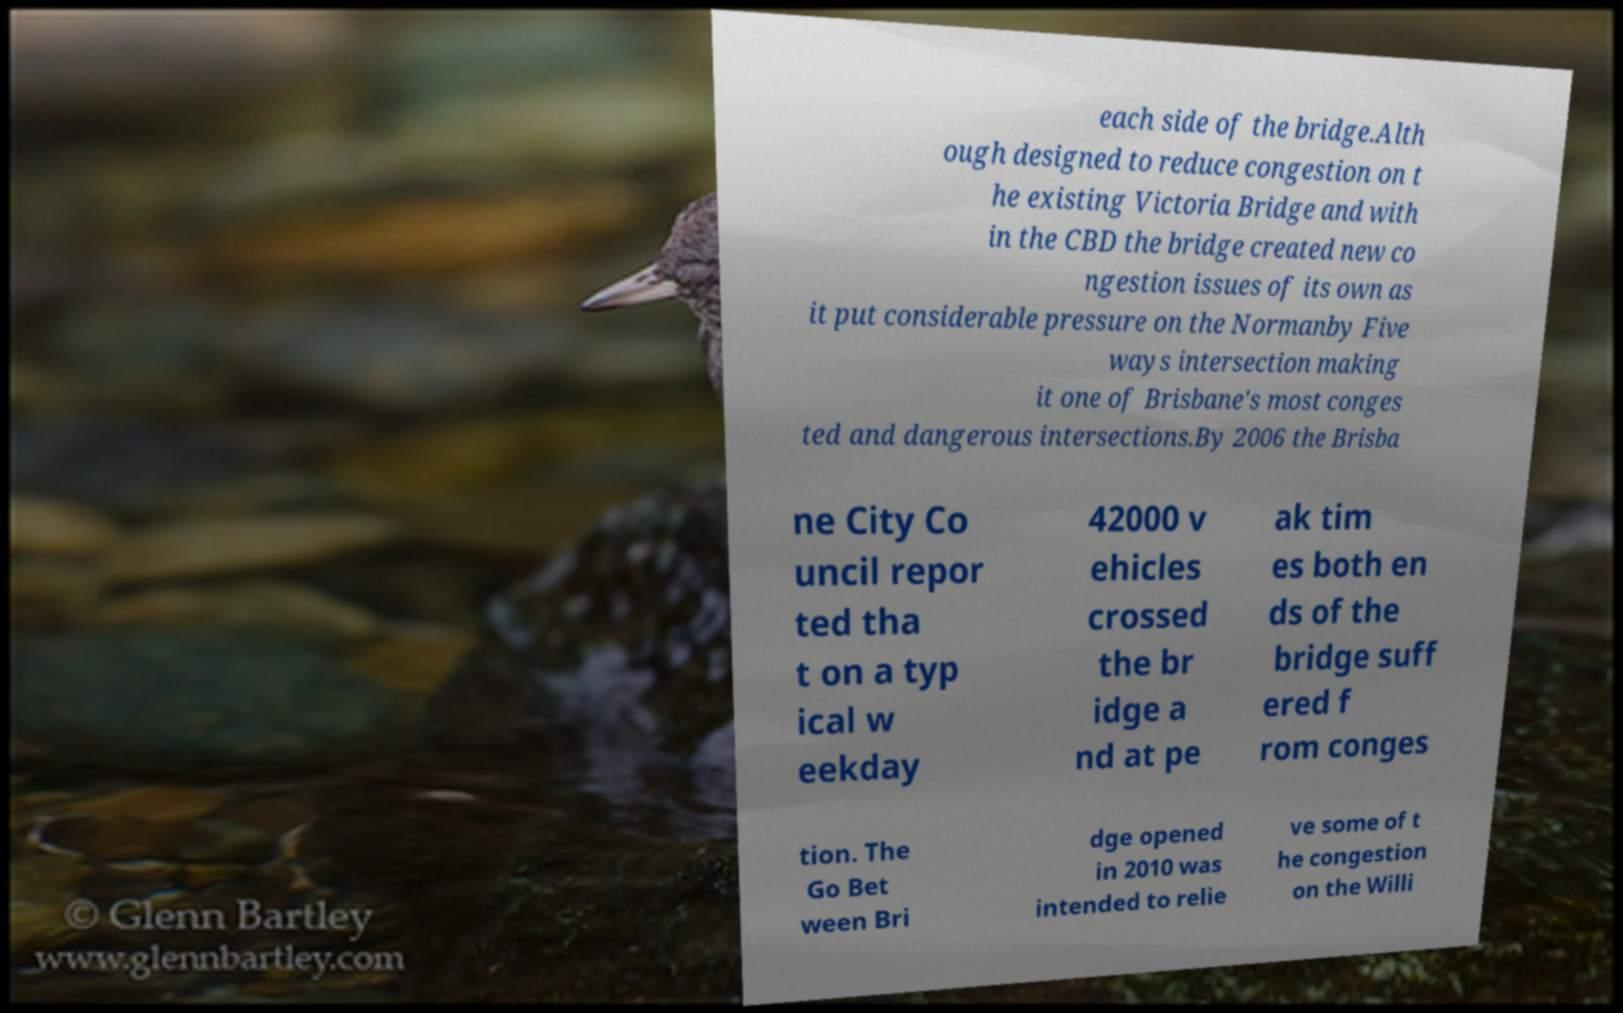Could you extract and type out the text from this image? each side of the bridge.Alth ough designed to reduce congestion on t he existing Victoria Bridge and with in the CBD the bridge created new co ngestion issues of its own as it put considerable pressure on the Normanby Five ways intersection making it one of Brisbane's most conges ted and dangerous intersections.By 2006 the Brisba ne City Co uncil repor ted tha t on a typ ical w eekday 42000 v ehicles crossed the br idge a nd at pe ak tim es both en ds of the bridge suff ered f rom conges tion. The Go Bet ween Bri dge opened in 2010 was intended to relie ve some of t he congestion on the Willi 